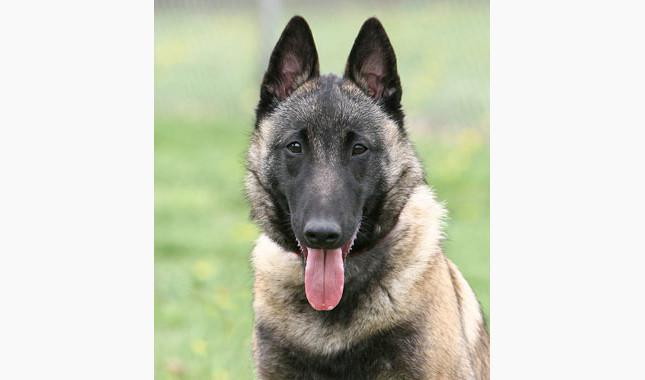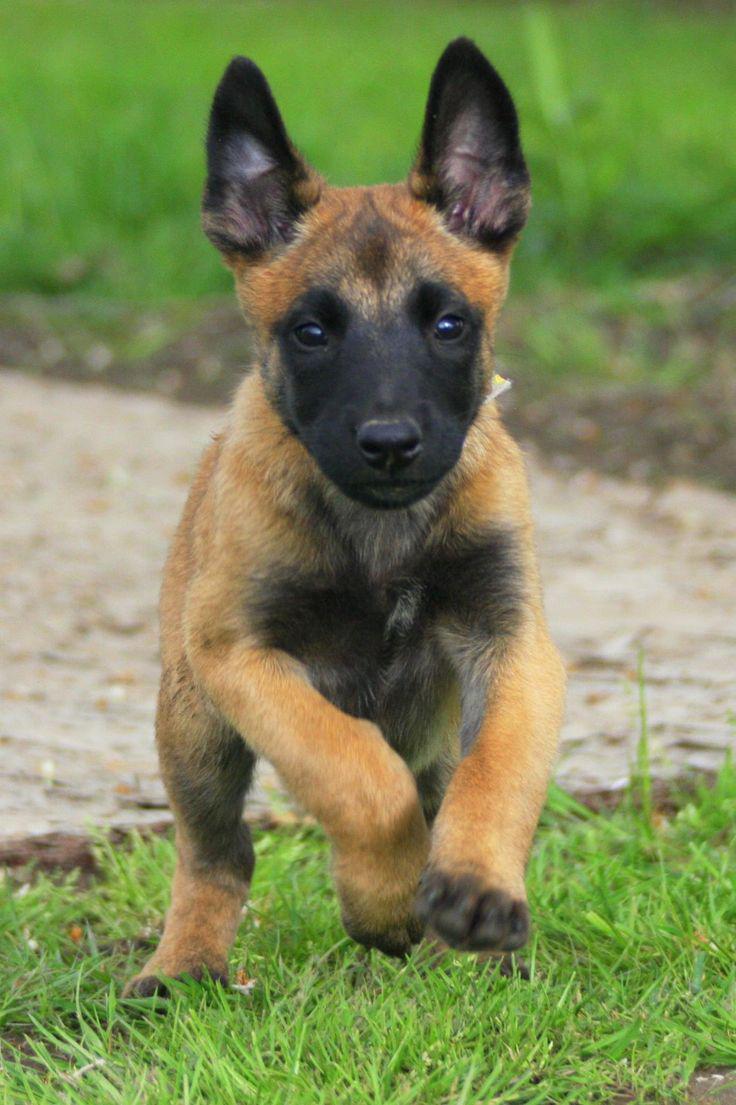The first image is the image on the left, the second image is the image on the right. Given the left and right images, does the statement "At least one dog has a red collar." hold true? Answer yes or no. No. 